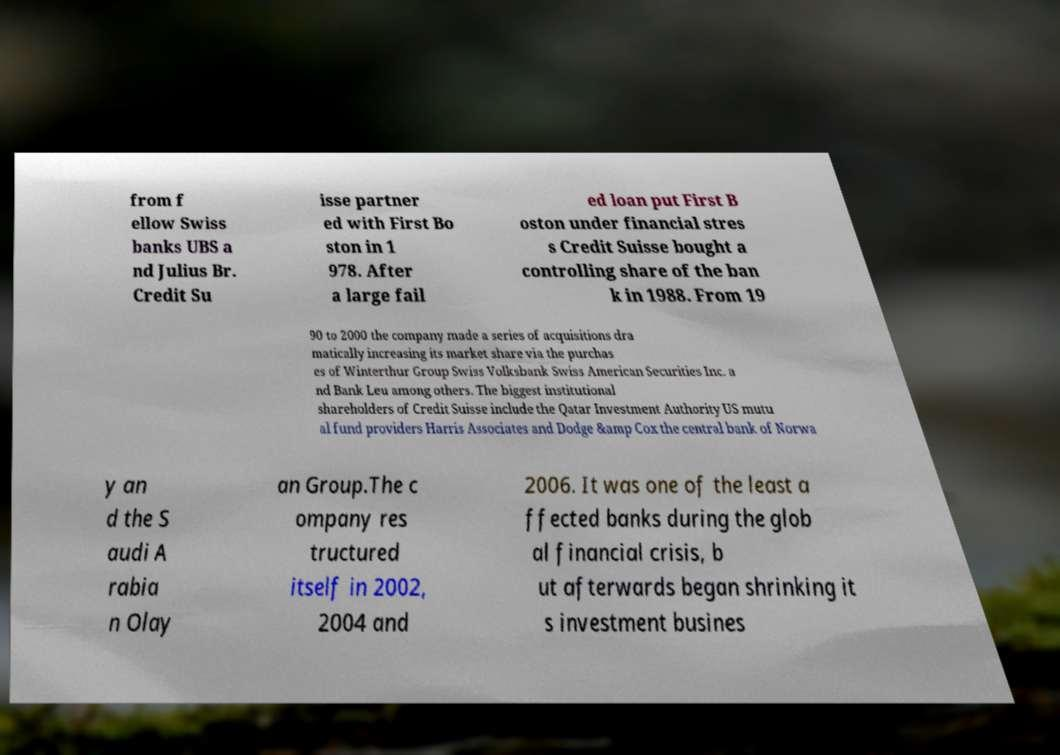For documentation purposes, I need the text within this image transcribed. Could you provide that? from f ellow Swiss banks UBS a nd Julius Br. Credit Su isse partner ed with First Bo ston in 1 978. After a large fail ed loan put First B oston under financial stres s Credit Suisse bought a controlling share of the ban k in 1988. From 19 90 to 2000 the company made a series of acquisitions dra matically increasing its market share via the purchas es of Winterthur Group Swiss Volksbank Swiss American Securities Inc. a nd Bank Leu among others. The biggest institutional shareholders of Credit Suisse include the Qatar Investment Authority US mutu al fund providers Harris Associates and Dodge &amp Cox the central bank of Norwa y an d the S audi A rabia n Olay an Group.The c ompany res tructured itself in 2002, 2004 and 2006. It was one of the least a ffected banks during the glob al financial crisis, b ut afterwards began shrinking it s investment busines 